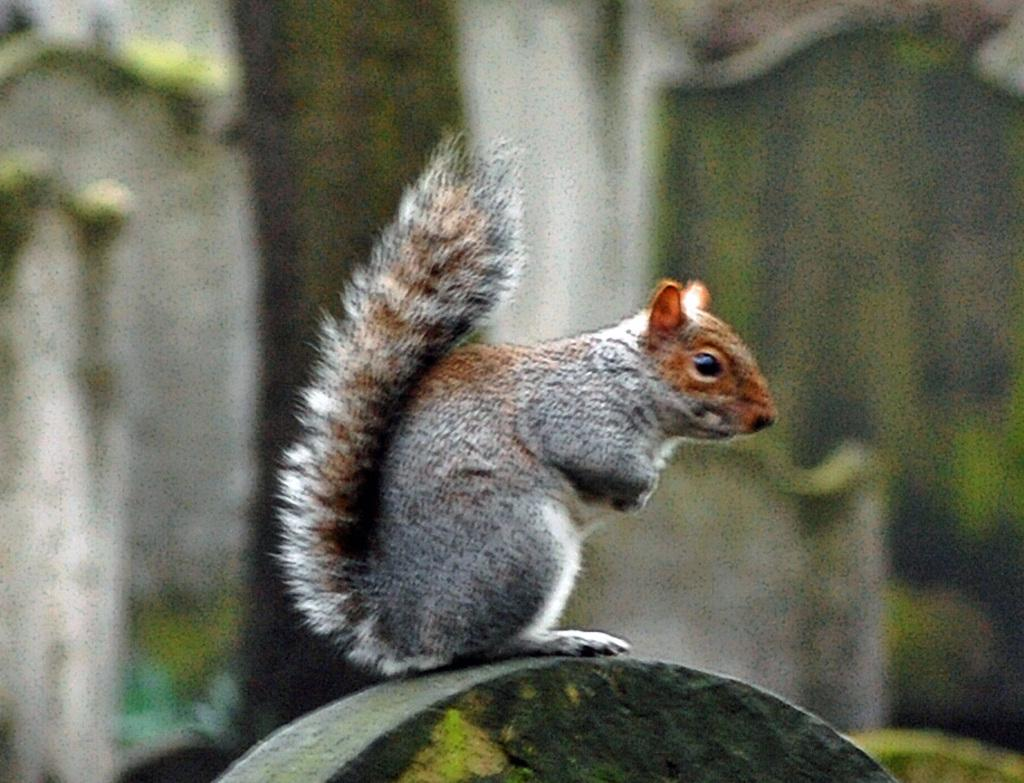What color is the object that the squirrel is on in the image? The object is green. Can you describe the squirrel in the image? The squirrel has a white and brown coloration. What is the squirrel doing on the green object? The provided facts do not specify the squirrel's actions. Where is the faucet located in the image? There is no faucet present in the image. Can you tell me the total cost of the items on the receipt in the image? There is no receipt present in the image. 